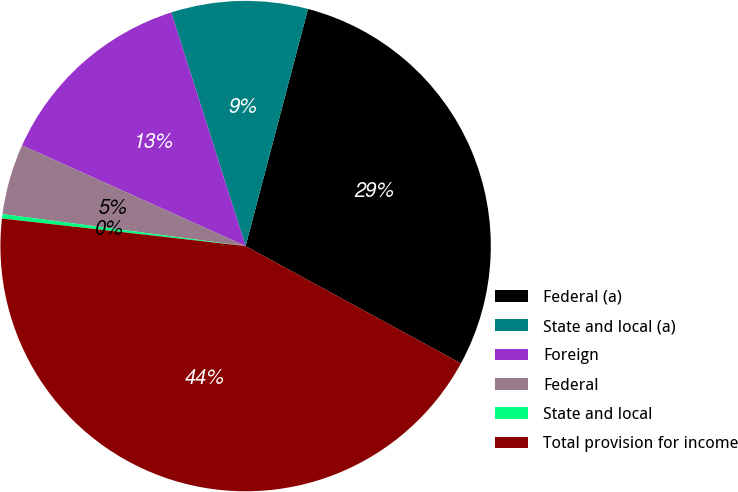<chart> <loc_0><loc_0><loc_500><loc_500><pie_chart><fcel>Federal (a)<fcel>State and local (a)<fcel>Foreign<fcel>Federal<fcel>State and local<fcel>Total provision for income<nl><fcel>28.84%<fcel>9.0%<fcel>13.36%<fcel>4.65%<fcel>0.29%<fcel>43.85%<nl></chart> 